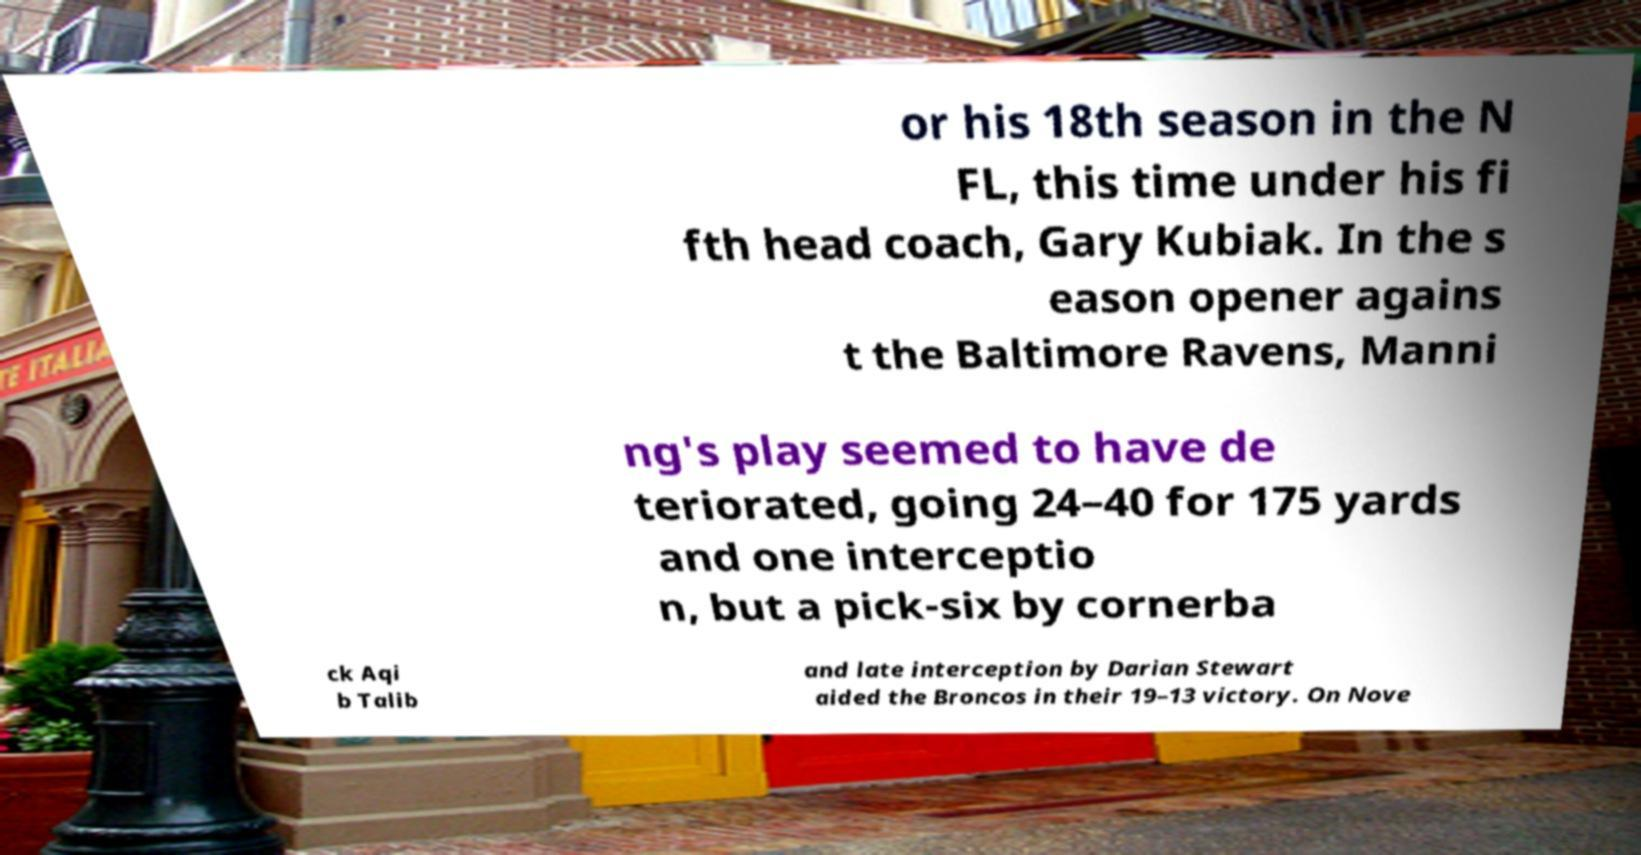Please read and relay the text visible in this image. What does it say? or his 18th season in the N FL, this time under his fi fth head coach, Gary Kubiak. In the s eason opener agains t the Baltimore Ravens, Manni ng's play seemed to have de teriorated, going 24–40 for 175 yards and one interceptio n, but a pick-six by cornerba ck Aqi b Talib and late interception by Darian Stewart aided the Broncos in their 19–13 victory. On Nove 